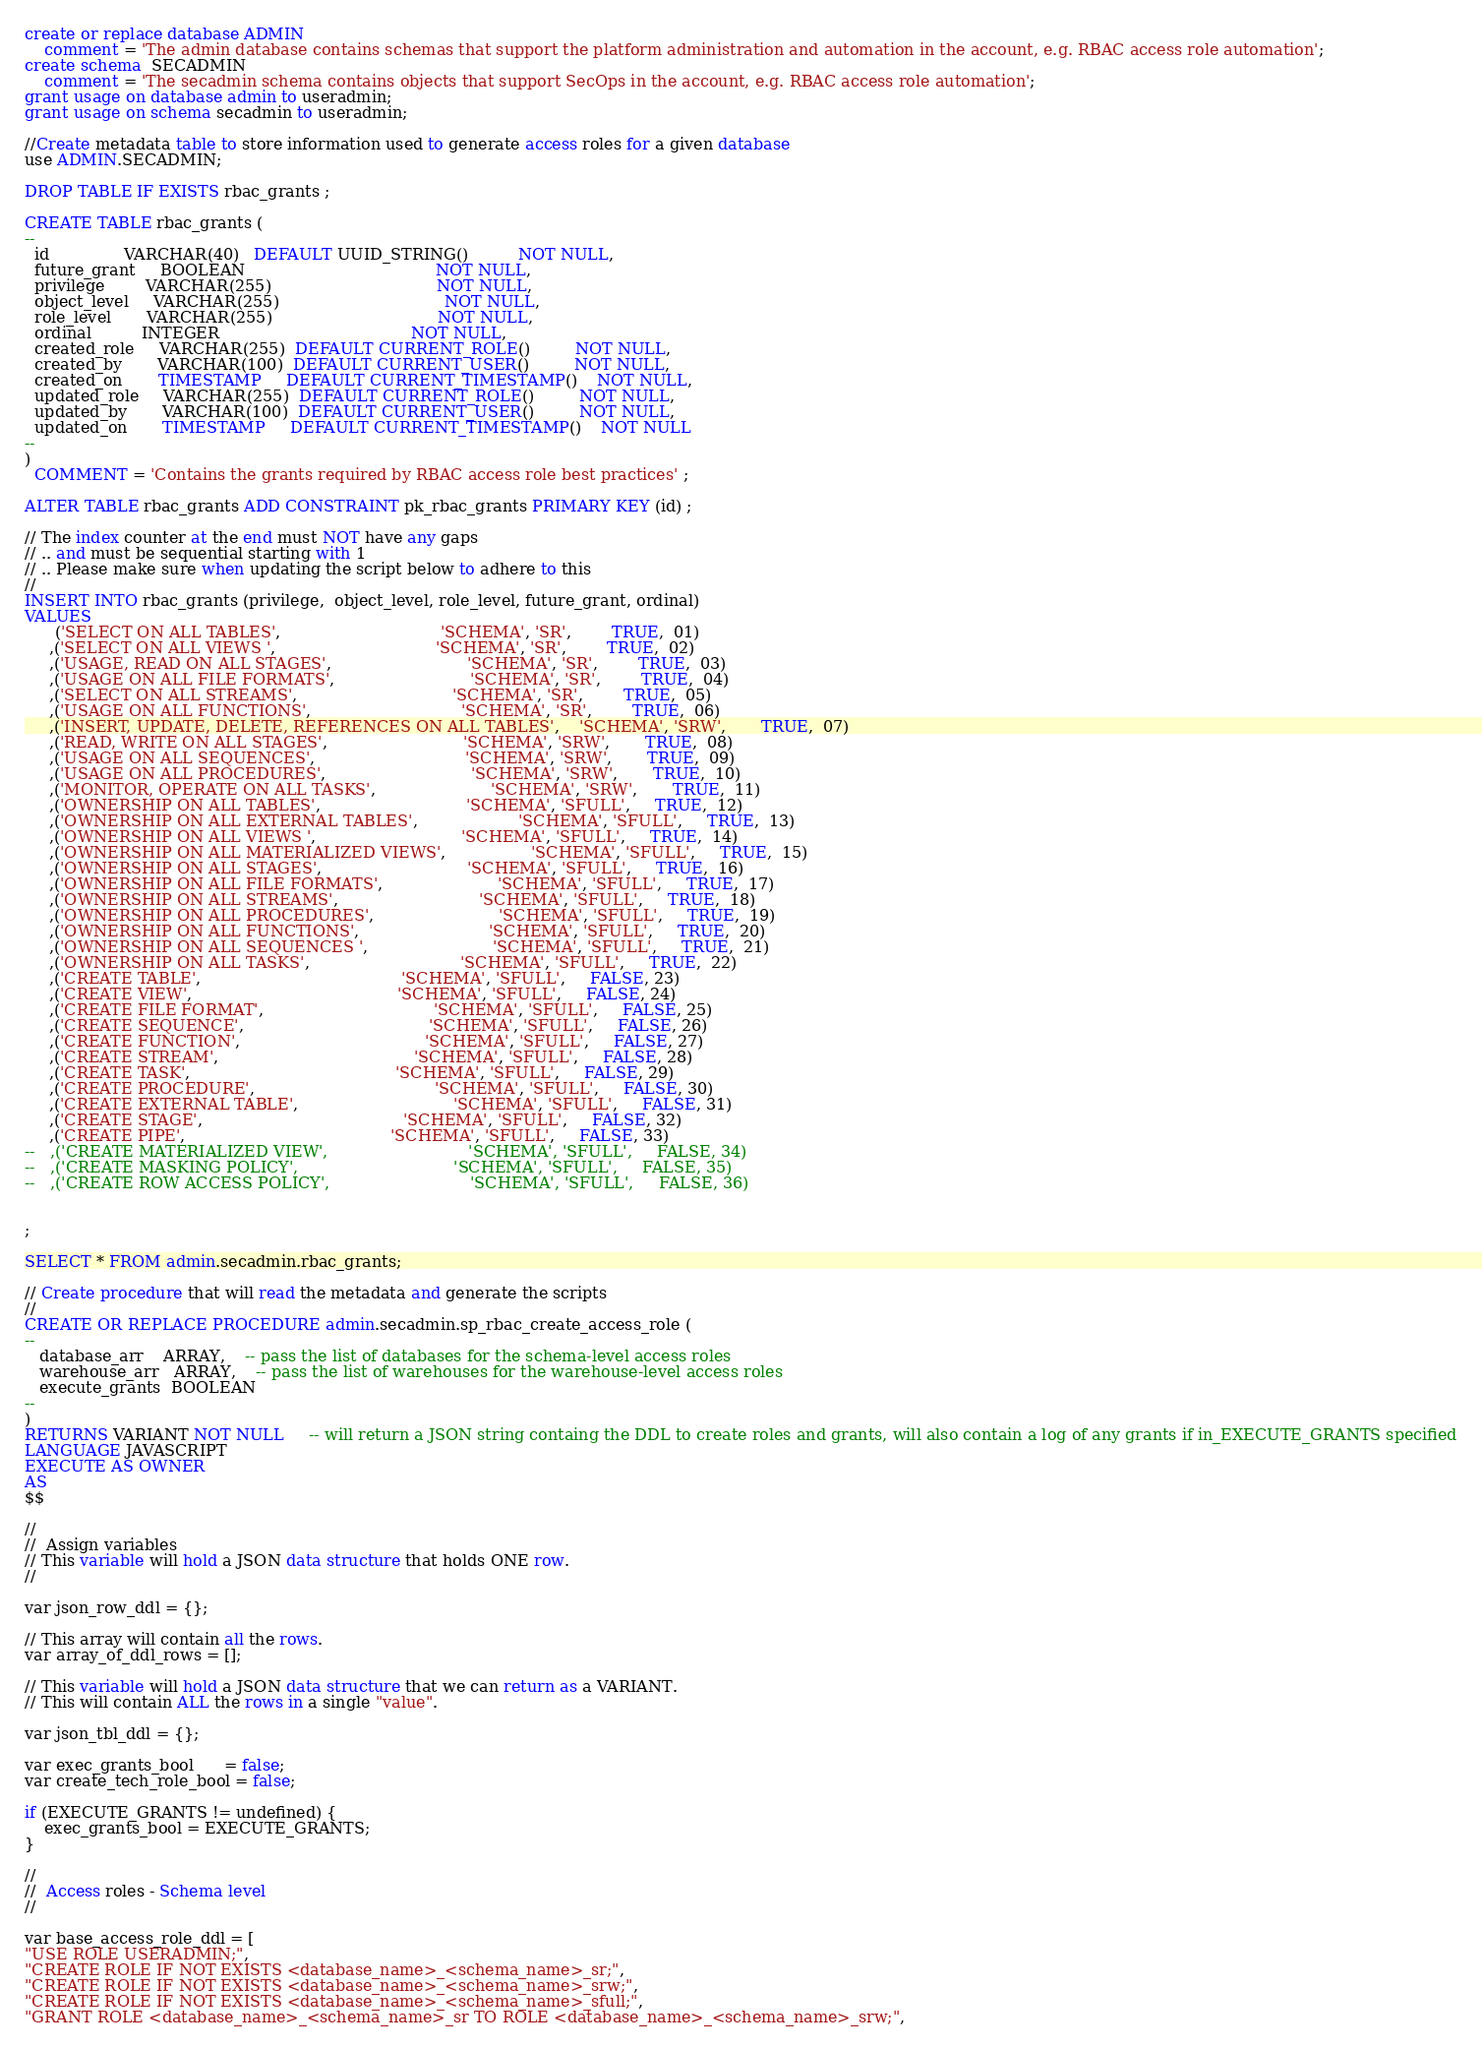Convert code to text. <code><loc_0><loc_0><loc_500><loc_500><_SQL_>create or replace database ADMIN
    comment = 'The admin database contains schemas that support the platform administration and automation in the account, e.g. RBAC access role automation';
create schema  SECADMIN
    comment = 'The secadmin schema contains objects that support SecOps in the account, e.g. RBAC access role automation';
grant usage on database admin to useradmin;
grant usage on schema secadmin to useradmin;

//Create metadata table to store information used to generate access roles for a given database
use ADMIN.SECADMIN;
    
DROP TABLE IF EXISTS rbac_grants ;

CREATE TABLE rbac_grants (
--
  id               VARCHAR(40)   DEFAULT UUID_STRING()          NOT NULL,
  future_grant     BOOLEAN                                      NOT NULL,
  privilege        VARCHAR(255)                                 NOT NULL,
  object_level     VARCHAR(255)                                 NOT NULL,
  role_level       VARCHAR(255)                                 NOT NULL,
  ordinal          INTEGER                                      NOT NULL,
  created_role     VARCHAR(255)  DEFAULT CURRENT_ROLE()         NOT NULL,
  created_by       VARCHAR(100)  DEFAULT CURRENT_USER()         NOT NULL,
  created_on       TIMESTAMP     DEFAULT CURRENT_TIMESTAMP()    NOT NULL,
  updated_role     VARCHAR(255)  DEFAULT CURRENT_ROLE()         NOT NULL,
  updated_by       VARCHAR(100)  DEFAULT CURRENT_USER()         NOT NULL,
  updated_on       TIMESTAMP     DEFAULT CURRENT_TIMESTAMP()    NOT NULL
--
) 
  COMMENT = 'Contains the grants required by RBAC access role best practices' ;

ALTER TABLE rbac_grants ADD CONSTRAINT pk_rbac_grants PRIMARY KEY (id) ;

// The index counter at the end must NOT have any gaps
// .. and must be sequential starting with 1
// .. Please make sure when updating the script below to adhere to this
//
INSERT INTO rbac_grants (privilege,  object_level, role_level, future_grant, ordinal)
VALUES
      ('SELECT ON ALL TABLES',                                'SCHEMA', 'SR',        TRUE,  01)
     ,('SELECT ON ALL VIEWS ',                                'SCHEMA', 'SR',        TRUE,  02)
     ,('USAGE, READ ON ALL STAGES',                           'SCHEMA', 'SR',        TRUE,  03)
     ,('USAGE ON ALL FILE FORMATS',                           'SCHEMA', 'SR',        TRUE,  04)
     ,('SELECT ON ALL STREAMS',                               'SCHEMA', 'SR',        TRUE,  05)
     ,('USAGE ON ALL FUNCTIONS',                              'SCHEMA', 'SR',        TRUE,  06)
     ,('INSERT, UPDATE, DELETE, REFERENCES ON ALL TABLES',    'SCHEMA', 'SRW',       TRUE,  07)
     ,('READ, WRITE ON ALL STAGES',                           'SCHEMA', 'SRW',       TRUE,  08)
     ,('USAGE ON ALL SEQUENCES',                              'SCHEMA', 'SRW',       TRUE,  09)
     ,('USAGE ON ALL PROCEDURES',                             'SCHEMA', 'SRW',       TRUE,  10)
     ,('MONITOR, OPERATE ON ALL TASKS',                       'SCHEMA', 'SRW',       TRUE,  11)
     ,('OWNERSHIP ON ALL TABLES',                             'SCHEMA', 'SFULL',     TRUE,  12)
     ,('OWNERSHIP ON ALL EXTERNAL TABLES',                    'SCHEMA', 'SFULL',     TRUE,  13)
     ,('OWNERSHIP ON ALL VIEWS ',                             'SCHEMA', 'SFULL',     TRUE,  14)
     ,('OWNERSHIP ON ALL MATERIALIZED VIEWS',                 'SCHEMA', 'SFULL',     TRUE,  15)
     ,('OWNERSHIP ON ALL STAGES',                             'SCHEMA', 'SFULL',     TRUE,  16)
     ,('OWNERSHIP ON ALL FILE FORMATS',                       'SCHEMA', 'SFULL',     TRUE,  17)
     ,('OWNERSHIP ON ALL STREAMS',                            'SCHEMA', 'SFULL',     TRUE,  18)
     ,('OWNERSHIP ON ALL PROCEDURES',                         'SCHEMA', 'SFULL',     TRUE,  19)
     ,('OWNERSHIP ON ALL FUNCTIONS',                          'SCHEMA', 'SFULL',     TRUE,  20)
     ,('OWNERSHIP ON ALL SEQUENCES ',                         'SCHEMA', 'SFULL',     TRUE,  21)
     ,('OWNERSHIP ON ALL TASKS',                              'SCHEMA', 'SFULL',     TRUE,  22)
     ,('CREATE TABLE',                                        'SCHEMA', 'SFULL',     FALSE, 23)
     ,('CREATE VIEW',                                         'SCHEMA', 'SFULL',     FALSE, 24)
     ,('CREATE FILE FORMAT',                                  'SCHEMA', 'SFULL',     FALSE, 25)
     ,('CREATE SEQUENCE',                                     'SCHEMA', 'SFULL',     FALSE, 26)
     ,('CREATE FUNCTION',                                     'SCHEMA', 'SFULL',     FALSE, 27)
     ,('CREATE STREAM',                                       'SCHEMA', 'SFULL',     FALSE, 28)
     ,('CREATE TASK',                                         'SCHEMA', 'SFULL',     FALSE, 29)
     ,('CREATE PROCEDURE',                                    'SCHEMA', 'SFULL',     FALSE, 30)
     ,('CREATE EXTERNAL TABLE',                               'SCHEMA', 'SFULL',     FALSE, 31)
     ,('CREATE STAGE',                                        'SCHEMA', 'SFULL',     FALSE, 32)
     ,('CREATE PIPE',                                         'SCHEMA', 'SFULL',     FALSE, 33)
--   ,('CREATE MATERIALIZED VIEW',                            'SCHEMA', 'SFULL',     FALSE, 34)
--   ,('CREATE MASKING POLICY',                               'SCHEMA', 'SFULL',     FALSE, 35)
--   ,('CREATE ROW ACCESS POLICY',                            'SCHEMA', 'SFULL',     FALSE, 36)

   
;

SELECT * FROM admin.secadmin.rbac_grants;

// Create procedure that will read the metadata and generate the scripts
//
CREATE OR REPLACE PROCEDURE admin.secadmin.sp_rbac_create_access_role (
--
   database_arr    ARRAY,    -- pass the list of databases for the schema-level access roles
   warehouse_arr   ARRAY,    -- pass the list of warehouses for the warehouse-level access roles
   execute_grants  BOOLEAN 
--
)
RETURNS VARIANT NOT NULL     -- will return a JSON string containg the DDL to create roles and grants, will also contain a log of any grants if in_EXECUTE_GRANTS specified
LANGUAGE JAVASCRIPT
EXECUTE AS OWNER
AS
$$

//
//  Assign variables
// This variable will hold a JSON data structure that holds ONE row.
//

var json_row_ddl = {};

// This array will contain all the rows.
var array_of_ddl_rows = [];

// This variable will hold a JSON data structure that we can return as a VARIANT.
// This will contain ALL the rows in a single "value".

var json_tbl_ddl = {};
   
var exec_grants_bool      = false;
var create_tech_role_bool = false;
   
if (EXECUTE_GRANTS != undefined) {
    exec_grants_bool = EXECUTE_GRANTS;
}

//
//  Access roles - Schema level
//

var base_access_role_ddl = [
"USE ROLE USERADMIN;",
"CREATE ROLE IF NOT EXISTS <database_name>_<schema_name>_sr;",
"CREATE ROLE IF NOT EXISTS <database_name>_<schema_name>_srw;",
"CREATE ROLE IF NOT EXISTS <database_name>_<schema_name>_sfull;",
"GRANT ROLE <database_name>_<schema_name>_sr TO ROLE <database_name>_<schema_name>_srw;",</code> 